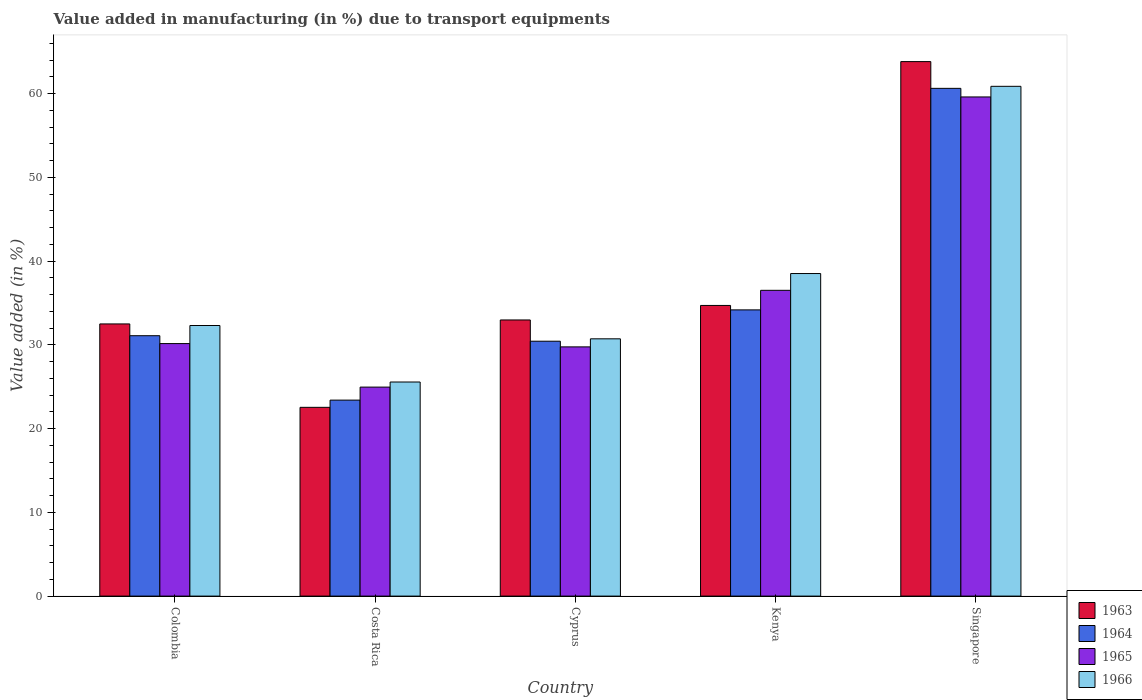How many different coloured bars are there?
Provide a short and direct response. 4. How many groups of bars are there?
Provide a short and direct response. 5. Are the number of bars per tick equal to the number of legend labels?
Offer a very short reply. Yes. Are the number of bars on each tick of the X-axis equal?
Offer a very short reply. Yes. What is the label of the 5th group of bars from the left?
Your answer should be compact. Singapore. In how many cases, is the number of bars for a given country not equal to the number of legend labels?
Provide a succinct answer. 0. What is the percentage of value added in manufacturing due to transport equipments in 1965 in Kenya?
Ensure brevity in your answer.  36.5. Across all countries, what is the maximum percentage of value added in manufacturing due to transport equipments in 1965?
Make the answer very short. 59.59. Across all countries, what is the minimum percentage of value added in manufacturing due to transport equipments in 1963?
Provide a succinct answer. 22.53. In which country was the percentage of value added in manufacturing due to transport equipments in 1964 maximum?
Keep it short and to the point. Singapore. In which country was the percentage of value added in manufacturing due to transport equipments in 1963 minimum?
Give a very brief answer. Costa Rica. What is the total percentage of value added in manufacturing due to transport equipments in 1963 in the graph?
Ensure brevity in your answer.  186.5. What is the difference between the percentage of value added in manufacturing due to transport equipments in 1965 in Cyprus and that in Kenya?
Ensure brevity in your answer.  -6.75. What is the difference between the percentage of value added in manufacturing due to transport equipments in 1966 in Cyprus and the percentage of value added in manufacturing due to transport equipments in 1963 in Colombia?
Your answer should be very brief. -1.78. What is the average percentage of value added in manufacturing due to transport equipments in 1966 per country?
Your answer should be very brief. 37.59. What is the difference between the percentage of value added in manufacturing due to transport equipments of/in 1963 and percentage of value added in manufacturing due to transport equipments of/in 1964 in Colombia?
Keep it short and to the point. 1.41. In how many countries, is the percentage of value added in manufacturing due to transport equipments in 1963 greater than 36 %?
Your answer should be very brief. 1. What is the ratio of the percentage of value added in manufacturing due to transport equipments in 1964 in Costa Rica to that in Cyprus?
Provide a succinct answer. 0.77. Is the difference between the percentage of value added in manufacturing due to transport equipments in 1963 in Costa Rica and Kenya greater than the difference between the percentage of value added in manufacturing due to transport equipments in 1964 in Costa Rica and Kenya?
Provide a succinct answer. No. What is the difference between the highest and the second highest percentage of value added in manufacturing due to transport equipments in 1964?
Make the answer very short. -26.45. What is the difference between the highest and the lowest percentage of value added in manufacturing due to transport equipments in 1963?
Ensure brevity in your answer.  41.28. What does the 4th bar from the right in Cyprus represents?
Your answer should be compact. 1963. How many bars are there?
Your answer should be compact. 20. How many countries are there in the graph?
Ensure brevity in your answer.  5. What is the difference between two consecutive major ticks on the Y-axis?
Ensure brevity in your answer.  10. Are the values on the major ticks of Y-axis written in scientific E-notation?
Give a very brief answer. No. Does the graph contain any zero values?
Offer a terse response. No. How many legend labels are there?
Give a very brief answer. 4. What is the title of the graph?
Ensure brevity in your answer.  Value added in manufacturing (in %) due to transport equipments. What is the label or title of the X-axis?
Your response must be concise. Country. What is the label or title of the Y-axis?
Your answer should be very brief. Value added (in %). What is the Value added (in %) in 1963 in Colombia?
Offer a terse response. 32.49. What is the Value added (in %) in 1964 in Colombia?
Ensure brevity in your answer.  31.09. What is the Value added (in %) in 1965 in Colombia?
Provide a short and direct response. 30.15. What is the Value added (in %) in 1966 in Colombia?
Offer a very short reply. 32.3. What is the Value added (in %) of 1963 in Costa Rica?
Offer a terse response. 22.53. What is the Value added (in %) in 1964 in Costa Rica?
Offer a terse response. 23.4. What is the Value added (in %) of 1965 in Costa Rica?
Make the answer very short. 24.95. What is the Value added (in %) of 1966 in Costa Rica?
Your answer should be very brief. 25.56. What is the Value added (in %) of 1963 in Cyprus?
Keep it short and to the point. 32.97. What is the Value added (in %) of 1964 in Cyprus?
Ensure brevity in your answer.  30.43. What is the Value added (in %) of 1965 in Cyprus?
Give a very brief answer. 29.75. What is the Value added (in %) in 1966 in Cyprus?
Provide a short and direct response. 30.72. What is the Value added (in %) of 1963 in Kenya?
Your response must be concise. 34.7. What is the Value added (in %) of 1964 in Kenya?
Your response must be concise. 34.17. What is the Value added (in %) in 1965 in Kenya?
Provide a short and direct response. 36.5. What is the Value added (in %) in 1966 in Kenya?
Keep it short and to the point. 38.51. What is the Value added (in %) of 1963 in Singapore?
Give a very brief answer. 63.81. What is the Value added (in %) in 1964 in Singapore?
Ensure brevity in your answer.  60.62. What is the Value added (in %) in 1965 in Singapore?
Your response must be concise. 59.59. What is the Value added (in %) of 1966 in Singapore?
Ensure brevity in your answer.  60.86. Across all countries, what is the maximum Value added (in %) of 1963?
Keep it short and to the point. 63.81. Across all countries, what is the maximum Value added (in %) in 1964?
Provide a succinct answer. 60.62. Across all countries, what is the maximum Value added (in %) of 1965?
Your answer should be compact. 59.59. Across all countries, what is the maximum Value added (in %) in 1966?
Your answer should be very brief. 60.86. Across all countries, what is the minimum Value added (in %) in 1963?
Give a very brief answer. 22.53. Across all countries, what is the minimum Value added (in %) of 1964?
Offer a very short reply. 23.4. Across all countries, what is the minimum Value added (in %) of 1965?
Offer a very short reply. 24.95. Across all countries, what is the minimum Value added (in %) in 1966?
Ensure brevity in your answer.  25.56. What is the total Value added (in %) in 1963 in the graph?
Offer a very short reply. 186.5. What is the total Value added (in %) of 1964 in the graph?
Your answer should be very brief. 179.7. What is the total Value added (in %) in 1965 in the graph?
Your answer should be very brief. 180.94. What is the total Value added (in %) of 1966 in the graph?
Keep it short and to the point. 187.95. What is the difference between the Value added (in %) in 1963 in Colombia and that in Costa Rica?
Make the answer very short. 9.96. What is the difference between the Value added (in %) in 1964 in Colombia and that in Costa Rica?
Give a very brief answer. 7.69. What is the difference between the Value added (in %) in 1965 in Colombia and that in Costa Rica?
Give a very brief answer. 5.2. What is the difference between the Value added (in %) in 1966 in Colombia and that in Costa Rica?
Give a very brief answer. 6.74. What is the difference between the Value added (in %) in 1963 in Colombia and that in Cyprus?
Make the answer very short. -0.47. What is the difference between the Value added (in %) in 1964 in Colombia and that in Cyprus?
Your answer should be compact. 0.66. What is the difference between the Value added (in %) in 1965 in Colombia and that in Cyprus?
Offer a very short reply. 0.39. What is the difference between the Value added (in %) in 1966 in Colombia and that in Cyprus?
Make the answer very short. 1.59. What is the difference between the Value added (in %) of 1963 in Colombia and that in Kenya?
Provide a succinct answer. -2.21. What is the difference between the Value added (in %) of 1964 in Colombia and that in Kenya?
Your response must be concise. -3.08. What is the difference between the Value added (in %) in 1965 in Colombia and that in Kenya?
Ensure brevity in your answer.  -6.36. What is the difference between the Value added (in %) of 1966 in Colombia and that in Kenya?
Your answer should be compact. -6.2. What is the difference between the Value added (in %) of 1963 in Colombia and that in Singapore?
Keep it short and to the point. -31.32. What is the difference between the Value added (in %) in 1964 in Colombia and that in Singapore?
Give a very brief answer. -29.53. What is the difference between the Value added (in %) of 1965 in Colombia and that in Singapore?
Your response must be concise. -29.45. What is the difference between the Value added (in %) of 1966 in Colombia and that in Singapore?
Make the answer very short. -28.56. What is the difference between the Value added (in %) in 1963 in Costa Rica and that in Cyprus?
Ensure brevity in your answer.  -10.43. What is the difference between the Value added (in %) of 1964 in Costa Rica and that in Cyprus?
Keep it short and to the point. -7.03. What is the difference between the Value added (in %) in 1965 in Costa Rica and that in Cyprus?
Offer a terse response. -4.8. What is the difference between the Value added (in %) of 1966 in Costa Rica and that in Cyprus?
Offer a terse response. -5.16. What is the difference between the Value added (in %) of 1963 in Costa Rica and that in Kenya?
Ensure brevity in your answer.  -12.17. What is the difference between the Value added (in %) in 1964 in Costa Rica and that in Kenya?
Offer a terse response. -10.77. What is the difference between the Value added (in %) in 1965 in Costa Rica and that in Kenya?
Offer a terse response. -11.55. What is the difference between the Value added (in %) in 1966 in Costa Rica and that in Kenya?
Ensure brevity in your answer.  -12.95. What is the difference between the Value added (in %) of 1963 in Costa Rica and that in Singapore?
Ensure brevity in your answer.  -41.28. What is the difference between the Value added (in %) of 1964 in Costa Rica and that in Singapore?
Your answer should be very brief. -37.22. What is the difference between the Value added (in %) of 1965 in Costa Rica and that in Singapore?
Offer a terse response. -34.64. What is the difference between the Value added (in %) of 1966 in Costa Rica and that in Singapore?
Keep it short and to the point. -35.3. What is the difference between the Value added (in %) in 1963 in Cyprus and that in Kenya?
Your answer should be very brief. -1.73. What is the difference between the Value added (in %) in 1964 in Cyprus and that in Kenya?
Your response must be concise. -3.74. What is the difference between the Value added (in %) in 1965 in Cyprus and that in Kenya?
Offer a terse response. -6.75. What is the difference between the Value added (in %) in 1966 in Cyprus and that in Kenya?
Provide a short and direct response. -7.79. What is the difference between the Value added (in %) of 1963 in Cyprus and that in Singapore?
Make the answer very short. -30.84. What is the difference between the Value added (in %) in 1964 in Cyprus and that in Singapore?
Give a very brief answer. -30.19. What is the difference between the Value added (in %) in 1965 in Cyprus and that in Singapore?
Give a very brief answer. -29.84. What is the difference between the Value added (in %) of 1966 in Cyprus and that in Singapore?
Make the answer very short. -30.14. What is the difference between the Value added (in %) of 1963 in Kenya and that in Singapore?
Ensure brevity in your answer.  -29.11. What is the difference between the Value added (in %) of 1964 in Kenya and that in Singapore?
Make the answer very short. -26.45. What is the difference between the Value added (in %) in 1965 in Kenya and that in Singapore?
Ensure brevity in your answer.  -23.09. What is the difference between the Value added (in %) in 1966 in Kenya and that in Singapore?
Provide a succinct answer. -22.35. What is the difference between the Value added (in %) in 1963 in Colombia and the Value added (in %) in 1964 in Costa Rica?
Your answer should be compact. 9.1. What is the difference between the Value added (in %) in 1963 in Colombia and the Value added (in %) in 1965 in Costa Rica?
Your response must be concise. 7.54. What is the difference between the Value added (in %) of 1963 in Colombia and the Value added (in %) of 1966 in Costa Rica?
Your answer should be very brief. 6.93. What is the difference between the Value added (in %) in 1964 in Colombia and the Value added (in %) in 1965 in Costa Rica?
Offer a very short reply. 6.14. What is the difference between the Value added (in %) in 1964 in Colombia and the Value added (in %) in 1966 in Costa Rica?
Make the answer very short. 5.53. What is the difference between the Value added (in %) of 1965 in Colombia and the Value added (in %) of 1966 in Costa Rica?
Provide a succinct answer. 4.59. What is the difference between the Value added (in %) in 1963 in Colombia and the Value added (in %) in 1964 in Cyprus?
Ensure brevity in your answer.  2.06. What is the difference between the Value added (in %) of 1963 in Colombia and the Value added (in %) of 1965 in Cyprus?
Keep it short and to the point. 2.74. What is the difference between the Value added (in %) in 1963 in Colombia and the Value added (in %) in 1966 in Cyprus?
Offer a terse response. 1.78. What is the difference between the Value added (in %) of 1964 in Colombia and the Value added (in %) of 1965 in Cyprus?
Provide a short and direct response. 1.33. What is the difference between the Value added (in %) in 1964 in Colombia and the Value added (in %) in 1966 in Cyprus?
Give a very brief answer. 0.37. What is the difference between the Value added (in %) of 1965 in Colombia and the Value added (in %) of 1966 in Cyprus?
Offer a very short reply. -0.57. What is the difference between the Value added (in %) in 1963 in Colombia and the Value added (in %) in 1964 in Kenya?
Provide a short and direct response. -1.68. What is the difference between the Value added (in %) of 1963 in Colombia and the Value added (in %) of 1965 in Kenya?
Offer a very short reply. -4.01. What is the difference between the Value added (in %) of 1963 in Colombia and the Value added (in %) of 1966 in Kenya?
Your response must be concise. -6.01. What is the difference between the Value added (in %) in 1964 in Colombia and the Value added (in %) in 1965 in Kenya?
Provide a succinct answer. -5.42. What is the difference between the Value added (in %) in 1964 in Colombia and the Value added (in %) in 1966 in Kenya?
Offer a terse response. -7.42. What is the difference between the Value added (in %) of 1965 in Colombia and the Value added (in %) of 1966 in Kenya?
Ensure brevity in your answer.  -8.36. What is the difference between the Value added (in %) in 1963 in Colombia and the Value added (in %) in 1964 in Singapore?
Provide a succinct answer. -28.12. What is the difference between the Value added (in %) in 1963 in Colombia and the Value added (in %) in 1965 in Singapore?
Give a very brief answer. -27.1. What is the difference between the Value added (in %) of 1963 in Colombia and the Value added (in %) of 1966 in Singapore?
Your answer should be compact. -28.37. What is the difference between the Value added (in %) of 1964 in Colombia and the Value added (in %) of 1965 in Singapore?
Your answer should be compact. -28.51. What is the difference between the Value added (in %) of 1964 in Colombia and the Value added (in %) of 1966 in Singapore?
Make the answer very short. -29.77. What is the difference between the Value added (in %) of 1965 in Colombia and the Value added (in %) of 1966 in Singapore?
Provide a succinct answer. -30.71. What is the difference between the Value added (in %) in 1963 in Costa Rica and the Value added (in %) in 1964 in Cyprus?
Ensure brevity in your answer.  -7.9. What is the difference between the Value added (in %) in 1963 in Costa Rica and the Value added (in %) in 1965 in Cyprus?
Offer a terse response. -7.22. What is the difference between the Value added (in %) in 1963 in Costa Rica and the Value added (in %) in 1966 in Cyprus?
Your answer should be compact. -8.18. What is the difference between the Value added (in %) in 1964 in Costa Rica and the Value added (in %) in 1965 in Cyprus?
Ensure brevity in your answer.  -6.36. What is the difference between the Value added (in %) of 1964 in Costa Rica and the Value added (in %) of 1966 in Cyprus?
Provide a succinct answer. -7.32. What is the difference between the Value added (in %) in 1965 in Costa Rica and the Value added (in %) in 1966 in Cyprus?
Provide a short and direct response. -5.77. What is the difference between the Value added (in %) of 1963 in Costa Rica and the Value added (in %) of 1964 in Kenya?
Give a very brief answer. -11.64. What is the difference between the Value added (in %) of 1963 in Costa Rica and the Value added (in %) of 1965 in Kenya?
Offer a terse response. -13.97. What is the difference between the Value added (in %) of 1963 in Costa Rica and the Value added (in %) of 1966 in Kenya?
Provide a succinct answer. -15.97. What is the difference between the Value added (in %) of 1964 in Costa Rica and the Value added (in %) of 1965 in Kenya?
Offer a very short reply. -13.11. What is the difference between the Value added (in %) in 1964 in Costa Rica and the Value added (in %) in 1966 in Kenya?
Provide a short and direct response. -15.11. What is the difference between the Value added (in %) in 1965 in Costa Rica and the Value added (in %) in 1966 in Kenya?
Offer a very short reply. -13.56. What is the difference between the Value added (in %) in 1963 in Costa Rica and the Value added (in %) in 1964 in Singapore?
Your answer should be very brief. -38.08. What is the difference between the Value added (in %) of 1963 in Costa Rica and the Value added (in %) of 1965 in Singapore?
Offer a very short reply. -37.06. What is the difference between the Value added (in %) in 1963 in Costa Rica and the Value added (in %) in 1966 in Singapore?
Provide a succinct answer. -38.33. What is the difference between the Value added (in %) of 1964 in Costa Rica and the Value added (in %) of 1965 in Singapore?
Provide a succinct answer. -36.19. What is the difference between the Value added (in %) in 1964 in Costa Rica and the Value added (in %) in 1966 in Singapore?
Offer a terse response. -37.46. What is the difference between the Value added (in %) in 1965 in Costa Rica and the Value added (in %) in 1966 in Singapore?
Your answer should be very brief. -35.91. What is the difference between the Value added (in %) in 1963 in Cyprus and the Value added (in %) in 1964 in Kenya?
Provide a succinct answer. -1.2. What is the difference between the Value added (in %) in 1963 in Cyprus and the Value added (in %) in 1965 in Kenya?
Your answer should be compact. -3.54. What is the difference between the Value added (in %) in 1963 in Cyprus and the Value added (in %) in 1966 in Kenya?
Give a very brief answer. -5.54. What is the difference between the Value added (in %) in 1964 in Cyprus and the Value added (in %) in 1965 in Kenya?
Ensure brevity in your answer.  -6.07. What is the difference between the Value added (in %) of 1964 in Cyprus and the Value added (in %) of 1966 in Kenya?
Your answer should be compact. -8.08. What is the difference between the Value added (in %) in 1965 in Cyprus and the Value added (in %) in 1966 in Kenya?
Make the answer very short. -8.75. What is the difference between the Value added (in %) in 1963 in Cyprus and the Value added (in %) in 1964 in Singapore?
Your response must be concise. -27.65. What is the difference between the Value added (in %) of 1963 in Cyprus and the Value added (in %) of 1965 in Singapore?
Your answer should be compact. -26.62. What is the difference between the Value added (in %) of 1963 in Cyprus and the Value added (in %) of 1966 in Singapore?
Make the answer very short. -27.89. What is the difference between the Value added (in %) of 1964 in Cyprus and the Value added (in %) of 1965 in Singapore?
Offer a very short reply. -29.16. What is the difference between the Value added (in %) in 1964 in Cyprus and the Value added (in %) in 1966 in Singapore?
Provide a short and direct response. -30.43. What is the difference between the Value added (in %) in 1965 in Cyprus and the Value added (in %) in 1966 in Singapore?
Your answer should be very brief. -31.11. What is the difference between the Value added (in %) in 1963 in Kenya and the Value added (in %) in 1964 in Singapore?
Ensure brevity in your answer.  -25.92. What is the difference between the Value added (in %) of 1963 in Kenya and the Value added (in %) of 1965 in Singapore?
Your answer should be compact. -24.89. What is the difference between the Value added (in %) in 1963 in Kenya and the Value added (in %) in 1966 in Singapore?
Provide a short and direct response. -26.16. What is the difference between the Value added (in %) in 1964 in Kenya and the Value added (in %) in 1965 in Singapore?
Ensure brevity in your answer.  -25.42. What is the difference between the Value added (in %) in 1964 in Kenya and the Value added (in %) in 1966 in Singapore?
Your answer should be compact. -26.69. What is the difference between the Value added (in %) of 1965 in Kenya and the Value added (in %) of 1966 in Singapore?
Offer a terse response. -24.36. What is the average Value added (in %) of 1963 per country?
Your response must be concise. 37.3. What is the average Value added (in %) in 1964 per country?
Give a very brief answer. 35.94. What is the average Value added (in %) of 1965 per country?
Your response must be concise. 36.19. What is the average Value added (in %) of 1966 per country?
Provide a short and direct response. 37.59. What is the difference between the Value added (in %) in 1963 and Value added (in %) in 1964 in Colombia?
Provide a short and direct response. 1.41. What is the difference between the Value added (in %) of 1963 and Value added (in %) of 1965 in Colombia?
Ensure brevity in your answer.  2.35. What is the difference between the Value added (in %) in 1963 and Value added (in %) in 1966 in Colombia?
Offer a very short reply. 0.19. What is the difference between the Value added (in %) in 1964 and Value added (in %) in 1965 in Colombia?
Your answer should be very brief. 0.94. What is the difference between the Value added (in %) in 1964 and Value added (in %) in 1966 in Colombia?
Offer a terse response. -1.22. What is the difference between the Value added (in %) in 1965 and Value added (in %) in 1966 in Colombia?
Make the answer very short. -2.16. What is the difference between the Value added (in %) in 1963 and Value added (in %) in 1964 in Costa Rica?
Your answer should be compact. -0.86. What is the difference between the Value added (in %) of 1963 and Value added (in %) of 1965 in Costa Rica?
Offer a very short reply. -2.42. What is the difference between the Value added (in %) of 1963 and Value added (in %) of 1966 in Costa Rica?
Your response must be concise. -3.03. What is the difference between the Value added (in %) in 1964 and Value added (in %) in 1965 in Costa Rica?
Your answer should be compact. -1.55. What is the difference between the Value added (in %) of 1964 and Value added (in %) of 1966 in Costa Rica?
Make the answer very short. -2.16. What is the difference between the Value added (in %) in 1965 and Value added (in %) in 1966 in Costa Rica?
Give a very brief answer. -0.61. What is the difference between the Value added (in %) in 1963 and Value added (in %) in 1964 in Cyprus?
Make the answer very short. 2.54. What is the difference between the Value added (in %) in 1963 and Value added (in %) in 1965 in Cyprus?
Make the answer very short. 3.21. What is the difference between the Value added (in %) of 1963 and Value added (in %) of 1966 in Cyprus?
Offer a terse response. 2.25. What is the difference between the Value added (in %) of 1964 and Value added (in %) of 1965 in Cyprus?
Ensure brevity in your answer.  0.68. What is the difference between the Value added (in %) in 1964 and Value added (in %) in 1966 in Cyprus?
Offer a terse response. -0.29. What is the difference between the Value added (in %) in 1965 and Value added (in %) in 1966 in Cyprus?
Give a very brief answer. -0.96. What is the difference between the Value added (in %) in 1963 and Value added (in %) in 1964 in Kenya?
Ensure brevity in your answer.  0.53. What is the difference between the Value added (in %) in 1963 and Value added (in %) in 1965 in Kenya?
Your answer should be compact. -1.8. What is the difference between the Value added (in %) in 1963 and Value added (in %) in 1966 in Kenya?
Make the answer very short. -3.81. What is the difference between the Value added (in %) in 1964 and Value added (in %) in 1965 in Kenya?
Offer a terse response. -2.33. What is the difference between the Value added (in %) of 1964 and Value added (in %) of 1966 in Kenya?
Make the answer very short. -4.34. What is the difference between the Value added (in %) in 1965 and Value added (in %) in 1966 in Kenya?
Your response must be concise. -2. What is the difference between the Value added (in %) of 1963 and Value added (in %) of 1964 in Singapore?
Your answer should be compact. 3.19. What is the difference between the Value added (in %) of 1963 and Value added (in %) of 1965 in Singapore?
Your response must be concise. 4.22. What is the difference between the Value added (in %) of 1963 and Value added (in %) of 1966 in Singapore?
Your response must be concise. 2.95. What is the difference between the Value added (in %) in 1964 and Value added (in %) in 1965 in Singapore?
Ensure brevity in your answer.  1.03. What is the difference between the Value added (in %) in 1964 and Value added (in %) in 1966 in Singapore?
Your response must be concise. -0.24. What is the difference between the Value added (in %) in 1965 and Value added (in %) in 1966 in Singapore?
Your answer should be very brief. -1.27. What is the ratio of the Value added (in %) of 1963 in Colombia to that in Costa Rica?
Give a very brief answer. 1.44. What is the ratio of the Value added (in %) in 1964 in Colombia to that in Costa Rica?
Your answer should be compact. 1.33. What is the ratio of the Value added (in %) in 1965 in Colombia to that in Costa Rica?
Offer a terse response. 1.21. What is the ratio of the Value added (in %) of 1966 in Colombia to that in Costa Rica?
Ensure brevity in your answer.  1.26. What is the ratio of the Value added (in %) of 1963 in Colombia to that in Cyprus?
Offer a terse response. 0.99. What is the ratio of the Value added (in %) of 1964 in Colombia to that in Cyprus?
Make the answer very short. 1.02. What is the ratio of the Value added (in %) in 1965 in Colombia to that in Cyprus?
Your answer should be very brief. 1.01. What is the ratio of the Value added (in %) in 1966 in Colombia to that in Cyprus?
Provide a succinct answer. 1.05. What is the ratio of the Value added (in %) of 1963 in Colombia to that in Kenya?
Your answer should be very brief. 0.94. What is the ratio of the Value added (in %) of 1964 in Colombia to that in Kenya?
Keep it short and to the point. 0.91. What is the ratio of the Value added (in %) of 1965 in Colombia to that in Kenya?
Offer a terse response. 0.83. What is the ratio of the Value added (in %) of 1966 in Colombia to that in Kenya?
Ensure brevity in your answer.  0.84. What is the ratio of the Value added (in %) of 1963 in Colombia to that in Singapore?
Provide a short and direct response. 0.51. What is the ratio of the Value added (in %) of 1964 in Colombia to that in Singapore?
Keep it short and to the point. 0.51. What is the ratio of the Value added (in %) in 1965 in Colombia to that in Singapore?
Ensure brevity in your answer.  0.51. What is the ratio of the Value added (in %) in 1966 in Colombia to that in Singapore?
Your response must be concise. 0.53. What is the ratio of the Value added (in %) in 1963 in Costa Rica to that in Cyprus?
Provide a short and direct response. 0.68. What is the ratio of the Value added (in %) in 1964 in Costa Rica to that in Cyprus?
Provide a short and direct response. 0.77. What is the ratio of the Value added (in %) of 1965 in Costa Rica to that in Cyprus?
Offer a terse response. 0.84. What is the ratio of the Value added (in %) of 1966 in Costa Rica to that in Cyprus?
Your answer should be compact. 0.83. What is the ratio of the Value added (in %) of 1963 in Costa Rica to that in Kenya?
Ensure brevity in your answer.  0.65. What is the ratio of the Value added (in %) of 1964 in Costa Rica to that in Kenya?
Provide a succinct answer. 0.68. What is the ratio of the Value added (in %) in 1965 in Costa Rica to that in Kenya?
Your answer should be very brief. 0.68. What is the ratio of the Value added (in %) of 1966 in Costa Rica to that in Kenya?
Your response must be concise. 0.66. What is the ratio of the Value added (in %) of 1963 in Costa Rica to that in Singapore?
Offer a terse response. 0.35. What is the ratio of the Value added (in %) of 1964 in Costa Rica to that in Singapore?
Offer a very short reply. 0.39. What is the ratio of the Value added (in %) of 1965 in Costa Rica to that in Singapore?
Offer a very short reply. 0.42. What is the ratio of the Value added (in %) in 1966 in Costa Rica to that in Singapore?
Offer a terse response. 0.42. What is the ratio of the Value added (in %) in 1963 in Cyprus to that in Kenya?
Offer a terse response. 0.95. What is the ratio of the Value added (in %) of 1964 in Cyprus to that in Kenya?
Your response must be concise. 0.89. What is the ratio of the Value added (in %) of 1965 in Cyprus to that in Kenya?
Provide a short and direct response. 0.82. What is the ratio of the Value added (in %) in 1966 in Cyprus to that in Kenya?
Your answer should be compact. 0.8. What is the ratio of the Value added (in %) in 1963 in Cyprus to that in Singapore?
Your answer should be compact. 0.52. What is the ratio of the Value added (in %) in 1964 in Cyprus to that in Singapore?
Provide a succinct answer. 0.5. What is the ratio of the Value added (in %) of 1965 in Cyprus to that in Singapore?
Your answer should be compact. 0.5. What is the ratio of the Value added (in %) in 1966 in Cyprus to that in Singapore?
Make the answer very short. 0.5. What is the ratio of the Value added (in %) in 1963 in Kenya to that in Singapore?
Provide a succinct answer. 0.54. What is the ratio of the Value added (in %) in 1964 in Kenya to that in Singapore?
Your response must be concise. 0.56. What is the ratio of the Value added (in %) of 1965 in Kenya to that in Singapore?
Your response must be concise. 0.61. What is the ratio of the Value added (in %) of 1966 in Kenya to that in Singapore?
Your answer should be compact. 0.63. What is the difference between the highest and the second highest Value added (in %) of 1963?
Your answer should be very brief. 29.11. What is the difference between the highest and the second highest Value added (in %) of 1964?
Your response must be concise. 26.45. What is the difference between the highest and the second highest Value added (in %) in 1965?
Offer a very short reply. 23.09. What is the difference between the highest and the second highest Value added (in %) in 1966?
Your answer should be very brief. 22.35. What is the difference between the highest and the lowest Value added (in %) in 1963?
Offer a terse response. 41.28. What is the difference between the highest and the lowest Value added (in %) of 1964?
Offer a terse response. 37.22. What is the difference between the highest and the lowest Value added (in %) of 1965?
Provide a short and direct response. 34.64. What is the difference between the highest and the lowest Value added (in %) of 1966?
Ensure brevity in your answer.  35.3. 